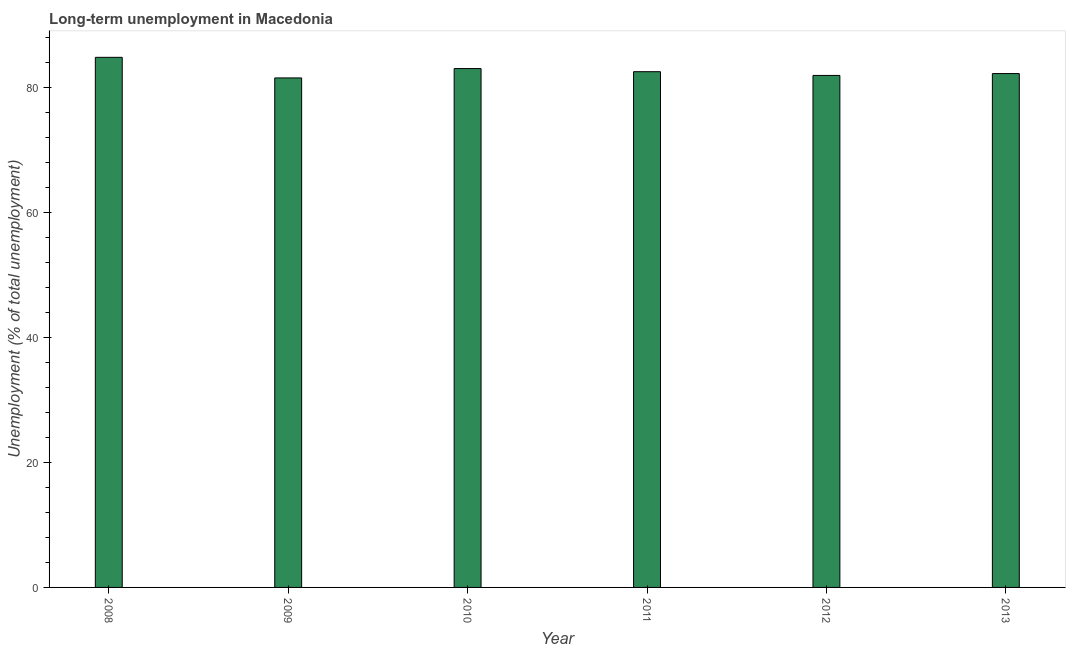Does the graph contain grids?
Keep it short and to the point. No. What is the title of the graph?
Offer a very short reply. Long-term unemployment in Macedonia. What is the label or title of the Y-axis?
Give a very brief answer. Unemployment (% of total unemployment). What is the long-term unemployment in 2010?
Make the answer very short. 83.1. Across all years, what is the maximum long-term unemployment?
Your answer should be very brief. 84.9. Across all years, what is the minimum long-term unemployment?
Offer a terse response. 81.6. In which year was the long-term unemployment maximum?
Offer a very short reply. 2008. What is the sum of the long-term unemployment?
Your answer should be compact. 496.5. What is the difference between the long-term unemployment in 2009 and 2011?
Your answer should be very brief. -1. What is the average long-term unemployment per year?
Keep it short and to the point. 82.75. What is the median long-term unemployment?
Provide a short and direct response. 82.45. Do a majority of the years between 2009 and 2013 (inclusive) have long-term unemployment greater than 24 %?
Your answer should be very brief. Yes. Is the sum of the long-term unemployment in 2012 and 2013 greater than the maximum long-term unemployment across all years?
Keep it short and to the point. Yes. In how many years, is the long-term unemployment greater than the average long-term unemployment taken over all years?
Keep it short and to the point. 2. How many bars are there?
Provide a succinct answer. 6. Are all the bars in the graph horizontal?
Make the answer very short. No. How many years are there in the graph?
Ensure brevity in your answer.  6. What is the difference between two consecutive major ticks on the Y-axis?
Offer a very short reply. 20. Are the values on the major ticks of Y-axis written in scientific E-notation?
Provide a succinct answer. No. What is the Unemployment (% of total unemployment) in 2008?
Offer a very short reply. 84.9. What is the Unemployment (% of total unemployment) in 2009?
Ensure brevity in your answer.  81.6. What is the Unemployment (% of total unemployment) of 2010?
Give a very brief answer. 83.1. What is the Unemployment (% of total unemployment) in 2011?
Your response must be concise. 82.6. What is the Unemployment (% of total unemployment) of 2013?
Your response must be concise. 82.3. What is the difference between the Unemployment (% of total unemployment) in 2008 and 2009?
Offer a very short reply. 3.3. What is the difference between the Unemployment (% of total unemployment) in 2008 and 2010?
Keep it short and to the point. 1.8. What is the difference between the Unemployment (% of total unemployment) in 2008 and 2012?
Give a very brief answer. 2.9. What is the difference between the Unemployment (% of total unemployment) in 2009 and 2010?
Provide a succinct answer. -1.5. What is the difference between the Unemployment (% of total unemployment) in 2009 and 2011?
Your answer should be very brief. -1. What is the difference between the Unemployment (% of total unemployment) in 2009 and 2012?
Offer a terse response. -0.4. What is the difference between the Unemployment (% of total unemployment) in 2009 and 2013?
Give a very brief answer. -0.7. What is the difference between the Unemployment (% of total unemployment) in 2010 and 2012?
Your response must be concise. 1.1. What is the difference between the Unemployment (% of total unemployment) in 2011 and 2012?
Your answer should be very brief. 0.6. What is the difference between the Unemployment (% of total unemployment) in 2011 and 2013?
Make the answer very short. 0.3. What is the difference between the Unemployment (% of total unemployment) in 2012 and 2013?
Your answer should be very brief. -0.3. What is the ratio of the Unemployment (% of total unemployment) in 2008 to that in 2009?
Provide a short and direct response. 1.04. What is the ratio of the Unemployment (% of total unemployment) in 2008 to that in 2011?
Ensure brevity in your answer.  1.03. What is the ratio of the Unemployment (% of total unemployment) in 2008 to that in 2012?
Offer a very short reply. 1.03. What is the ratio of the Unemployment (% of total unemployment) in 2008 to that in 2013?
Provide a succinct answer. 1.03. What is the ratio of the Unemployment (% of total unemployment) in 2009 to that in 2012?
Give a very brief answer. 0.99. What is the ratio of the Unemployment (% of total unemployment) in 2010 to that in 2011?
Keep it short and to the point. 1.01. What is the ratio of the Unemployment (% of total unemployment) in 2010 to that in 2013?
Offer a very short reply. 1.01. What is the ratio of the Unemployment (% of total unemployment) in 2011 to that in 2012?
Your answer should be compact. 1.01. What is the ratio of the Unemployment (% of total unemployment) in 2011 to that in 2013?
Provide a short and direct response. 1. 